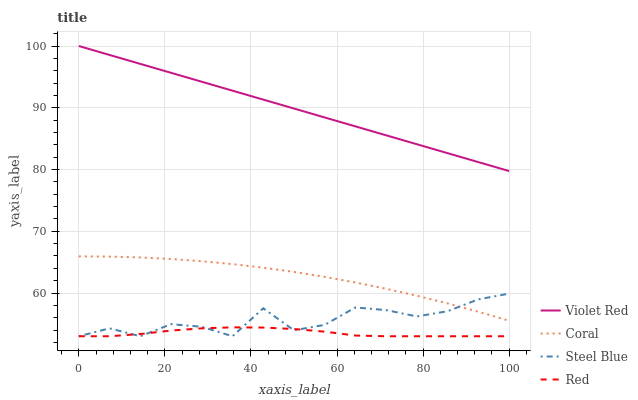Does Red have the minimum area under the curve?
Answer yes or no. Yes. Does Violet Red have the maximum area under the curve?
Answer yes or no. Yes. Does Coral have the minimum area under the curve?
Answer yes or no. No. Does Coral have the maximum area under the curve?
Answer yes or no. No. Is Violet Red the smoothest?
Answer yes or no. Yes. Is Steel Blue the roughest?
Answer yes or no. Yes. Is Coral the smoothest?
Answer yes or no. No. Is Coral the roughest?
Answer yes or no. No. Does Red have the lowest value?
Answer yes or no. Yes. Does Coral have the lowest value?
Answer yes or no. No. Does Violet Red have the highest value?
Answer yes or no. Yes. Does Coral have the highest value?
Answer yes or no. No. Is Red less than Coral?
Answer yes or no. Yes. Is Violet Red greater than Coral?
Answer yes or no. Yes. Does Steel Blue intersect Red?
Answer yes or no. Yes. Is Steel Blue less than Red?
Answer yes or no. No. Is Steel Blue greater than Red?
Answer yes or no. No. Does Red intersect Coral?
Answer yes or no. No. 